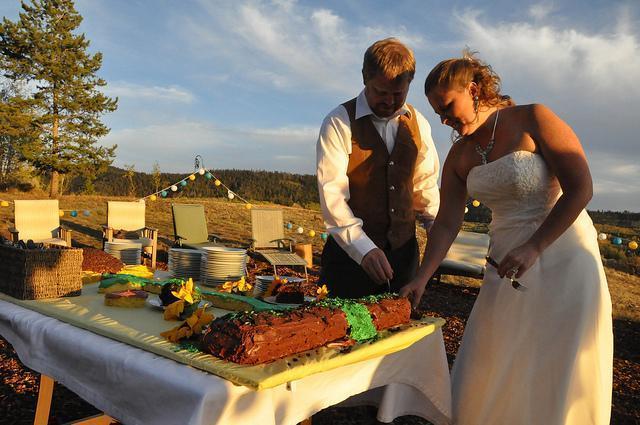How many people?
Give a very brief answer. 2. How many people are there?
Give a very brief answer. 2. How many chairs are visible?
Give a very brief answer. 2. How many windows are on the train in the picture?
Give a very brief answer. 0. 